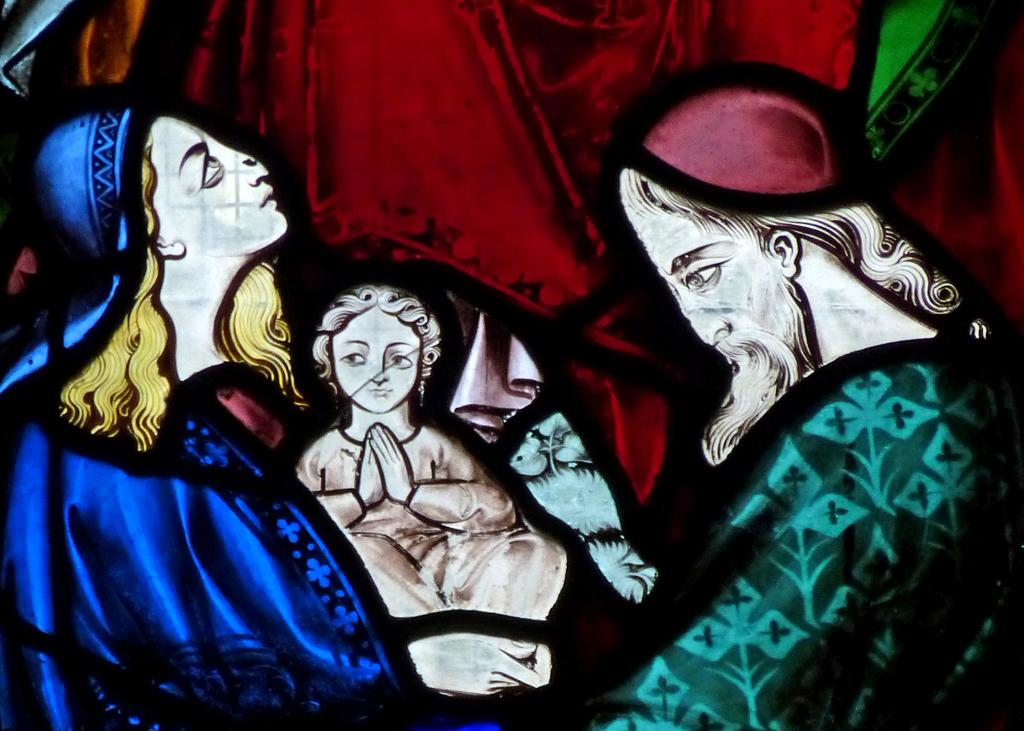How many people are in the image? There are two persons in the image. What else can be seen in the image besides the people? There is a baby in the image. What colors are the people wearing? One or more of the persons are wearing blue or green color dress. What colors are present in the background of the image? The background of the image has red and green colors. What type of music can be heard playing in the background of the image? There is no music present in the image, as it is a still photograph. 